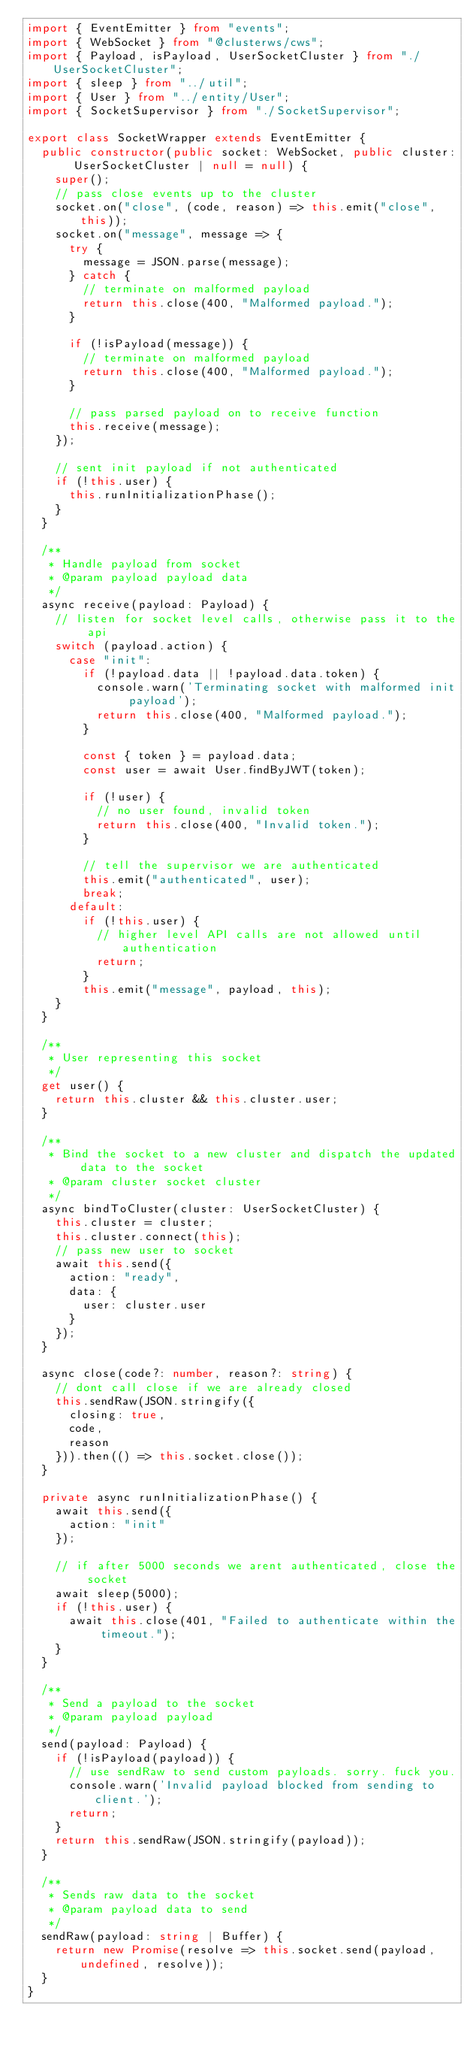<code> <loc_0><loc_0><loc_500><loc_500><_TypeScript_>import { EventEmitter } from "events";
import { WebSocket } from "@clusterws/cws";
import { Payload, isPayload, UserSocketCluster } from "./UserSocketCluster";
import { sleep } from "../util";
import { User } from "../entity/User";
import { SocketSupervisor } from "./SocketSupervisor";

export class SocketWrapper extends EventEmitter {
  public constructor(public socket: WebSocket, public cluster: UserSocketCluster | null = null) {
    super();
    // pass close events up to the cluster
    socket.on("close", (code, reason) => this.emit("close", this));
    socket.on("message", message => {
      try {
        message = JSON.parse(message);
      } catch {
        // terminate on malformed payload
        return this.close(400, "Malformed payload.");
      }

      if (!isPayload(message)) {
        // terminate on malformed payload
        return this.close(400, "Malformed payload.");
      }

      // pass parsed payload on to receive function
      this.receive(message);
    });

    // sent init payload if not authenticated
    if (!this.user) {
      this.runInitializationPhase();
    }
  }

  /**
   * Handle payload from socket
   * @param payload payload data
   */
  async receive(payload: Payload) {
    // listen for socket level calls, otherwise pass it to the api
    switch (payload.action) {
      case "init":
        if (!payload.data || !payload.data.token) {
          console.warn('Terminating socket with malformed init payload');
          return this.close(400, "Malformed payload.");
        }

        const { token } = payload.data;
        const user = await User.findByJWT(token);

        if (!user) {
          // no user found, invalid token
          return this.close(400, "Invalid token.");
        }

        // tell the supervisor we are authenticated
        this.emit("authenticated", user);
        break;
      default:
        if (!this.user) {
          // higher level API calls are not allowed until authentication
          return;
        }
        this.emit("message", payload, this);
    }
  }

  /**
   * User representing this socket
   */
  get user() {
    return this.cluster && this.cluster.user;
  }

  /**
   * Bind the socket to a new cluster and dispatch the updated data to the socket
   * @param cluster socket cluster
   */
  async bindToCluster(cluster: UserSocketCluster) {
    this.cluster = cluster;
    this.cluster.connect(this);
    // pass new user to socket
    await this.send({
      action: "ready",
      data: {
        user: cluster.user
      }
    });
  }

  async close(code?: number, reason?: string) {
    // dont call close if we are already closed
    this.sendRaw(JSON.stringify({
      closing: true,
      code,
      reason
    })).then(() => this.socket.close());
  }

  private async runInitializationPhase() {
    await this.send({
      action: "init"
    });

    // if after 5000 seconds we arent authenticated, close the socket
    await sleep(5000);
    if (!this.user) {
      await this.close(401, "Failed to authenticate within the timeout.");
    }
  }

  /**
   * Send a payload to the socket
   * @param payload payload
   */
  send(payload: Payload) {
    if (!isPayload(payload)) {
      // use sendRaw to send custom payloads. sorry. fuck you.
      console.warn('Invalid payload blocked from sending to client.');
      return;
    }
    return this.sendRaw(JSON.stringify(payload));
  }

  /**
   * Sends raw data to the socket
   * @param payload data to send
   */
  sendRaw(payload: string | Buffer) {
    return new Promise(resolve => this.socket.send(payload, undefined, resolve));
  }
}</code> 